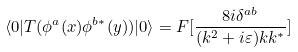Convert formula to latex. <formula><loc_0><loc_0><loc_500><loc_500>\langle 0 | T ( \phi ^ { a } ( x ) \phi ^ { b * } ( y ) ) | 0 \rangle = F [ \frac { 8 i \delta ^ { a b } } { ( k ^ { 2 } + i \varepsilon ) k k ^ { * } } ]</formula> 